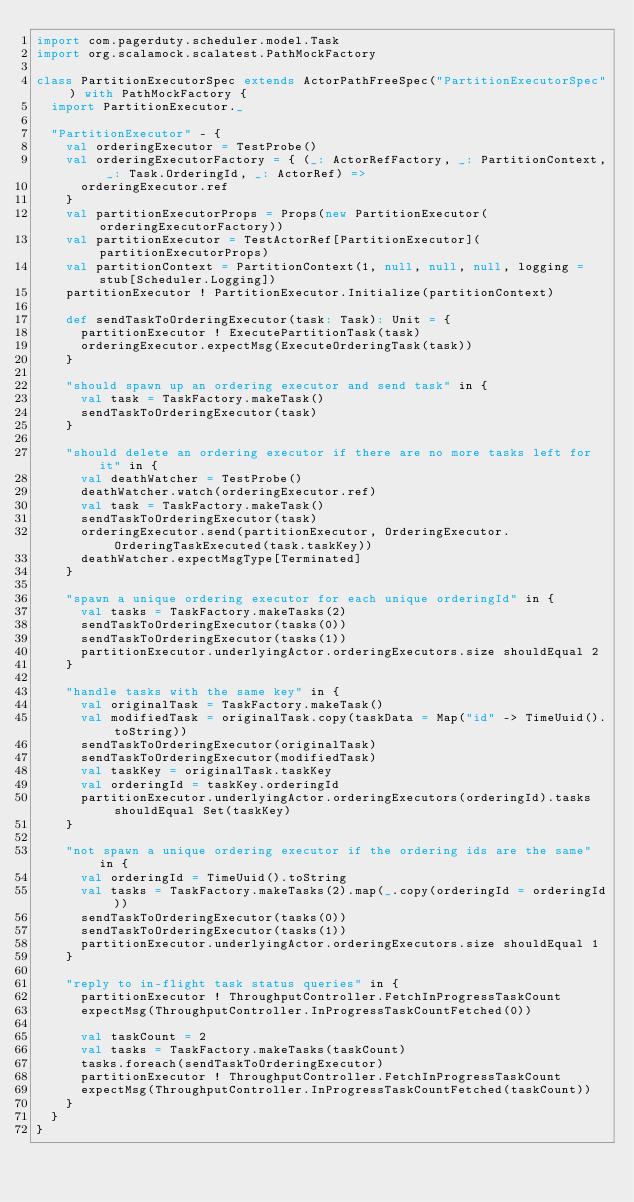Convert code to text. <code><loc_0><loc_0><loc_500><loc_500><_Scala_>import com.pagerduty.scheduler.model.Task
import org.scalamock.scalatest.PathMockFactory

class PartitionExecutorSpec extends ActorPathFreeSpec("PartitionExecutorSpec") with PathMockFactory {
  import PartitionExecutor._

  "PartitionExecutor" - {
    val orderingExecutor = TestProbe()
    val orderingExecutorFactory = { (_: ActorRefFactory, _: PartitionContext, _: Task.OrderingId, _: ActorRef) =>
      orderingExecutor.ref
    }
    val partitionExecutorProps = Props(new PartitionExecutor(orderingExecutorFactory))
    val partitionExecutor = TestActorRef[PartitionExecutor](partitionExecutorProps)
    val partitionContext = PartitionContext(1, null, null, null, logging = stub[Scheduler.Logging])
    partitionExecutor ! PartitionExecutor.Initialize(partitionContext)

    def sendTaskToOrderingExecutor(task: Task): Unit = {
      partitionExecutor ! ExecutePartitionTask(task)
      orderingExecutor.expectMsg(ExecuteOrderingTask(task))
    }

    "should spawn up an ordering executor and send task" in {
      val task = TaskFactory.makeTask()
      sendTaskToOrderingExecutor(task)
    }

    "should delete an ordering executor if there are no more tasks left for it" in {
      val deathWatcher = TestProbe()
      deathWatcher.watch(orderingExecutor.ref)
      val task = TaskFactory.makeTask()
      sendTaskToOrderingExecutor(task)
      orderingExecutor.send(partitionExecutor, OrderingExecutor.OrderingTaskExecuted(task.taskKey))
      deathWatcher.expectMsgType[Terminated]
    }

    "spawn a unique ordering executor for each unique orderingId" in {
      val tasks = TaskFactory.makeTasks(2)
      sendTaskToOrderingExecutor(tasks(0))
      sendTaskToOrderingExecutor(tasks(1))
      partitionExecutor.underlyingActor.orderingExecutors.size shouldEqual 2
    }

    "handle tasks with the same key" in {
      val originalTask = TaskFactory.makeTask()
      val modifiedTask = originalTask.copy(taskData = Map("id" -> TimeUuid().toString))
      sendTaskToOrderingExecutor(originalTask)
      sendTaskToOrderingExecutor(modifiedTask)
      val taskKey = originalTask.taskKey
      val orderingId = taskKey.orderingId
      partitionExecutor.underlyingActor.orderingExecutors(orderingId).tasks shouldEqual Set(taskKey)
    }

    "not spawn a unique ordering executor if the ordering ids are the same" in {
      val orderingId = TimeUuid().toString
      val tasks = TaskFactory.makeTasks(2).map(_.copy(orderingId = orderingId))
      sendTaskToOrderingExecutor(tasks(0))
      sendTaskToOrderingExecutor(tasks(1))
      partitionExecutor.underlyingActor.orderingExecutors.size shouldEqual 1
    }

    "reply to in-flight task status queries" in {
      partitionExecutor ! ThroughputController.FetchInProgressTaskCount
      expectMsg(ThroughputController.InProgressTaskCountFetched(0))

      val taskCount = 2
      val tasks = TaskFactory.makeTasks(taskCount)
      tasks.foreach(sendTaskToOrderingExecutor)
      partitionExecutor ! ThroughputController.FetchInProgressTaskCount
      expectMsg(ThroughputController.InProgressTaskCountFetched(taskCount))
    }
  }
}
</code> 